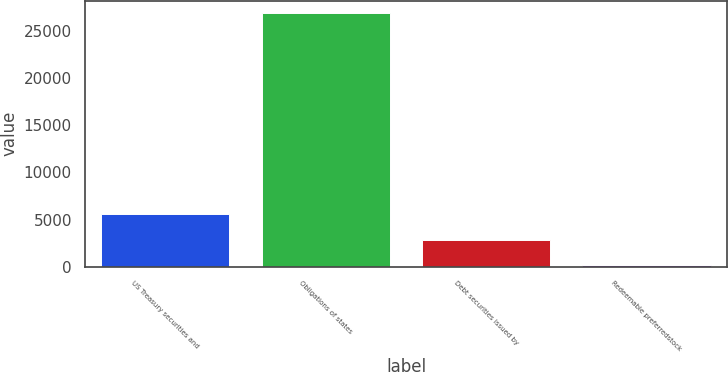Convert chart. <chart><loc_0><loc_0><loc_500><loc_500><bar_chart><fcel>US Treasury securities and<fcel>Obligations of states<fcel>Debt securities issued by<fcel>Redeemable preferredstock<nl><fcel>5537<fcel>26841<fcel>2874<fcel>211<nl></chart> 